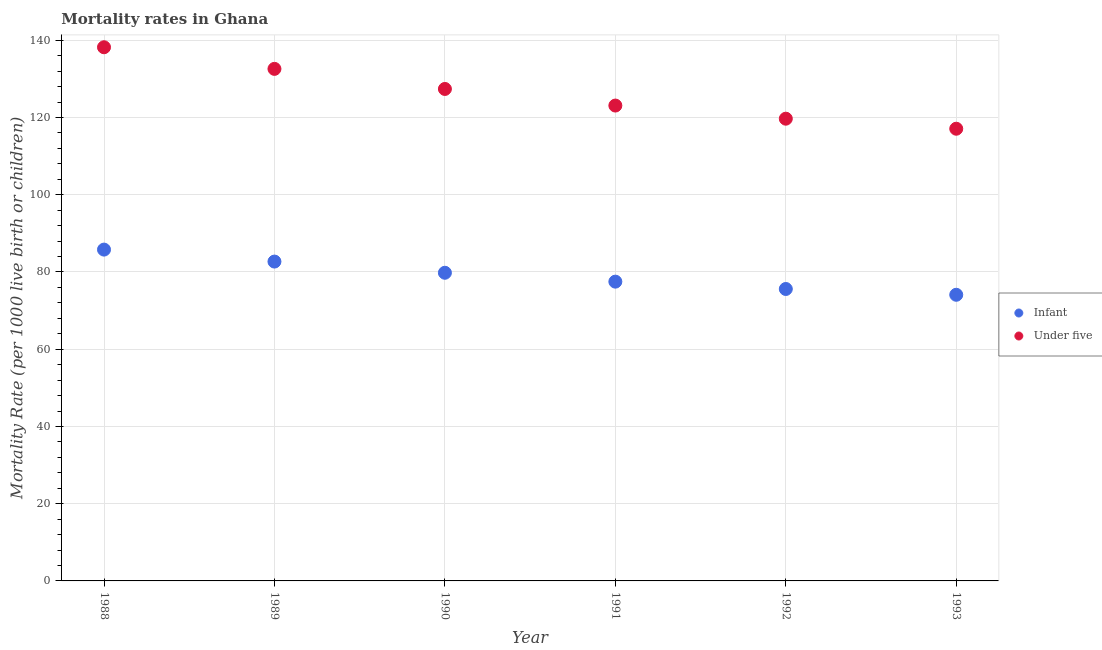Is the number of dotlines equal to the number of legend labels?
Ensure brevity in your answer.  Yes. What is the infant mortality rate in 1993?
Provide a short and direct response. 74.1. Across all years, what is the maximum infant mortality rate?
Your response must be concise. 85.8. Across all years, what is the minimum under-5 mortality rate?
Offer a very short reply. 117.1. In which year was the infant mortality rate maximum?
Give a very brief answer. 1988. What is the total infant mortality rate in the graph?
Your answer should be compact. 475.5. What is the difference between the infant mortality rate in 1988 and that in 1990?
Provide a succinct answer. 6. What is the difference between the infant mortality rate in 1993 and the under-5 mortality rate in 1992?
Offer a very short reply. -45.6. What is the average infant mortality rate per year?
Ensure brevity in your answer.  79.25. In the year 1993, what is the difference between the under-5 mortality rate and infant mortality rate?
Make the answer very short. 43. What is the ratio of the infant mortality rate in 1989 to that in 1990?
Keep it short and to the point. 1.04. Is the difference between the infant mortality rate in 1991 and 1992 greater than the difference between the under-5 mortality rate in 1991 and 1992?
Offer a very short reply. No. What is the difference between the highest and the second highest infant mortality rate?
Make the answer very short. 3.1. What is the difference between the highest and the lowest under-5 mortality rate?
Provide a short and direct response. 21.1. In how many years, is the under-5 mortality rate greater than the average under-5 mortality rate taken over all years?
Keep it short and to the point. 3. Is the sum of the infant mortality rate in 1992 and 1993 greater than the maximum under-5 mortality rate across all years?
Give a very brief answer. Yes. Is the under-5 mortality rate strictly less than the infant mortality rate over the years?
Offer a very short reply. No. How many dotlines are there?
Ensure brevity in your answer.  2. What is the difference between two consecutive major ticks on the Y-axis?
Your answer should be very brief. 20. Are the values on the major ticks of Y-axis written in scientific E-notation?
Keep it short and to the point. No. Does the graph contain any zero values?
Offer a terse response. No. Where does the legend appear in the graph?
Provide a succinct answer. Center right. How many legend labels are there?
Ensure brevity in your answer.  2. How are the legend labels stacked?
Your response must be concise. Vertical. What is the title of the graph?
Your response must be concise. Mortality rates in Ghana. Does "From human activities" appear as one of the legend labels in the graph?
Give a very brief answer. No. What is the label or title of the X-axis?
Make the answer very short. Year. What is the label or title of the Y-axis?
Your response must be concise. Mortality Rate (per 1000 live birth or children). What is the Mortality Rate (per 1000 live birth or children) in Infant in 1988?
Provide a succinct answer. 85.8. What is the Mortality Rate (per 1000 live birth or children) of Under five in 1988?
Your response must be concise. 138.2. What is the Mortality Rate (per 1000 live birth or children) in Infant in 1989?
Offer a very short reply. 82.7. What is the Mortality Rate (per 1000 live birth or children) in Under five in 1989?
Offer a very short reply. 132.6. What is the Mortality Rate (per 1000 live birth or children) of Infant in 1990?
Offer a terse response. 79.8. What is the Mortality Rate (per 1000 live birth or children) of Under five in 1990?
Ensure brevity in your answer.  127.4. What is the Mortality Rate (per 1000 live birth or children) of Infant in 1991?
Your response must be concise. 77.5. What is the Mortality Rate (per 1000 live birth or children) in Under five in 1991?
Give a very brief answer. 123.1. What is the Mortality Rate (per 1000 live birth or children) in Infant in 1992?
Your answer should be very brief. 75.6. What is the Mortality Rate (per 1000 live birth or children) in Under five in 1992?
Your answer should be very brief. 119.7. What is the Mortality Rate (per 1000 live birth or children) in Infant in 1993?
Ensure brevity in your answer.  74.1. What is the Mortality Rate (per 1000 live birth or children) in Under five in 1993?
Provide a short and direct response. 117.1. Across all years, what is the maximum Mortality Rate (per 1000 live birth or children) of Infant?
Provide a succinct answer. 85.8. Across all years, what is the maximum Mortality Rate (per 1000 live birth or children) in Under five?
Ensure brevity in your answer.  138.2. Across all years, what is the minimum Mortality Rate (per 1000 live birth or children) of Infant?
Offer a terse response. 74.1. Across all years, what is the minimum Mortality Rate (per 1000 live birth or children) in Under five?
Your answer should be compact. 117.1. What is the total Mortality Rate (per 1000 live birth or children) in Infant in the graph?
Offer a very short reply. 475.5. What is the total Mortality Rate (per 1000 live birth or children) in Under five in the graph?
Offer a very short reply. 758.1. What is the difference between the Mortality Rate (per 1000 live birth or children) of Under five in 1988 and that in 1989?
Your answer should be compact. 5.6. What is the difference between the Mortality Rate (per 1000 live birth or children) in Infant in 1988 and that in 1991?
Offer a terse response. 8.3. What is the difference between the Mortality Rate (per 1000 live birth or children) in Infant in 1988 and that in 1992?
Offer a terse response. 10.2. What is the difference between the Mortality Rate (per 1000 live birth or children) in Infant in 1988 and that in 1993?
Make the answer very short. 11.7. What is the difference between the Mortality Rate (per 1000 live birth or children) of Under five in 1988 and that in 1993?
Give a very brief answer. 21.1. What is the difference between the Mortality Rate (per 1000 live birth or children) in Infant in 1989 and that in 1990?
Your response must be concise. 2.9. What is the difference between the Mortality Rate (per 1000 live birth or children) of Under five in 1989 and that in 1990?
Provide a short and direct response. 5.2. What is the difference between the Mortality Rate (per 1000 live birth or children) of Infant in 1989 and that in 1991?
Ensure brevity in your answer.  5.2. What is the difference between the Mortality Rate (per 1000 live birth or children) of Under five in 1989 and that in 1991?
Your answer should be very brief. 9.5. What is the difference between the Mortality Rate (per 1000 live birth or children) of Under five in 1989 and that in 1992?
Make the answer very short. 12.9. What is the difference between the Mortality Rate (per 1000 live birth or children) of Infant in 1990 and that in 1991?
Keep it short and to the point. 2.3. What is the difference between the Mortality Rate (per 1000 live birth or children) in Infant in 1990 and that in 1992?
Ensure brevity in your answer.  4.2. What is the difference between the Mortality Rate (per 1000 live birth or children) of Under five in 1990 and that in 1993?
Keep it short and to the point. 10.3. What is the difference between the Mortality Rate (per 1000 live birth or children) of Infant in 1991 and that in 1993?
Offer a terse response. 3.4. What is the difference between the Mortality Rate (per 1000 live birth or children) of Infant in 1988 and the Mortality Rate (per 1000 live birth or children) of Under five in 1989?
Ensure brevity in your answer.  -46.8. What is the difference between the Mortality Rate (per 1000 live birth or children) of Infant in 1988 and the Mortality Rate (per 1000 live birth or children) of Under five in 1990?
Your answer should be very brief. -41.6. What is the difference between the Mortality Rate (per 1000 live birth or children) in Infant in 1988 and the Mortality Rate (per 1000 live birth or children) in Under five in 1991?
Give a very brief answer. -37.3. What is the difference between the Mortality Rate (per 1000 live birth or children) in Infant in 1988 and the Mortality Rate (per 1000 live birth or children) in Under five in 1992?
Your response must be concise. -33.9. What is the difference between the Mortality Rate (per 1000 live birth or children) of Infant in 1988 and the Mortality Rate (per 1000 live birth or children) of Under five in 1993?
Keep it short and to the point. -31.3. What is the difference between the Mortality Rate (per 1000 live birth or children) of Infant in 1989 and the Mortality Rate (per 1000 live birth or children) of Under five in 1990?
Your answer should be compact. -44.7. What is the difference between the Mortality Rate (per 1000 live birth or children) in Infant in 1989 and the Mortality Rate (per 1000 live birth or children) in Under five in 1991?
Your response must be concise. -40.4. What is the difference between the Mortality Rate (per 1000 live birth or children) in Infant in 1989 and the Mortality Rate (per 1000 live birth or children) in Under five in 1992?
Make the answer very short. -37. What is the difference between the Mortality Rate (per 1000 live birth or children) of Infant in 1989 and the Mortality Rate (per 1000 live birth or children) of Under five in 1993?
Your answer should be compact. -34.4. What is the difference between the Mortality Rate (per 1000 live birth or children) of Infant in 1990 and the Mortality Rate (per 1000 live birth or children) of Under five in 1991?
Offer a very short reply. -43.3. What is the difference between the Mortality Rate (per 1000 live birth or children) in Infant in 1990 and the Mortality Rate (per 1000 live birth or children) in Under five in 1992?
Provide a succinct answer. -39.9. What is the difference between the Mortality Rate (per 1000 live birth or children) in Infant in 1990 and the Mortality Rate (per 1000 live birth or children) in Under five in 1993?
Keep it short and to the point. -37.3. What is the difference between the Mortality Rate (per 1000 live birth or children) of Infant in 1991 and the Mortality Rate (per 1000 live birth or children) of Under five in 1992?
Provide a succinct answer. -42.2. What is the difference between the Mortality Rate (per 1000 live birth or children) in Infant in 1991 and the Mortality Rate (per 1000 live birth or children) in Under five in 1993?
Make the answer very short. -39.6. What is the difference between the Mortality Rate (per 1000 live birth or children) in Infant in 1992 and the Mortality Rate (per 1000 live birth or children) in Under five in 1993?
Ensure brevity in your answer.  -41.5. What is the average Mortality Rate (per 1000 live birth or children) in Infant per year?
Make the answer very short. 79.25. What is the average Mortality Rate (per 1000 live birth or children) in Under five per year?
Your answer should be very brief. 126.35. In the year 1988, what is the difference between the Mortality Rate (per 1000 live birth or children) of Infant and Mortality Rate (per 1000 live birth or children) of Under five?
Offer a very short reply. -52.4. In the year 1989, what is the difference between the Mortality Rate (per 1000 live birth or children) of Infant and Mortality Rate (per 1000 live birth or children) of Under five?
Offer a very short reply. -49.9. In the year 1990, what is the difference between the Mortality Rate (per 1000 live birth or children) of Infant and Mortality Rate (per 1000 live birth or children) of Under five?
Provide a short and direct response. -47.6. In the year 1991, what is the difference between the Mortality Rate (per 1000 live birth or children) in Infant and Mortality Rate (per 1000 live birth or children) in Under five?
Make the answer very short. -45.6. In the year 1992, what is the difference between the Mortality Rate (per 1000 live birth or children) in Infant and Mortality Rate (per 1000 live birth or children) in Under five?
Offer a very short reply. -44.1. In the year 1993, what is the difference between the Mortality Rate (per 1000 live birth or children) of Infant and Mortality Rate (per 1000 live birth or children) of Under five?
Provide a short and direct response. -43. What is the ratio of the Mortality Rate (per 1000 live birth or children) in Infant in 1988 to that in 1989?
Keep it short and to the point. 1.04. What is the ratio of the Mortality Rate (per 1000 live birth or children) in Under five in 1988 to that in 1989?
Give a very brief answer. 1.04. What is the ratio of the Mortality Rate (per 1000 live birth or children) in Infant in 1988 to that in 1990?
Make the answer very short. 1.08. What is the ratio of the Mortality Rate (per 1000 live birth or children) of Under five in 1988 to that in 1990?
Ensure brevity in your answer.  1.08. What is the ratio of the Mortality Rate (per 1000 live birth or children) of Infant in 1988 to that in 1991?
Ensure brevity in your answer.  1.11. What is the ratio of the Mortality Rate (per 1000 live birth or children) of Under five in 1988 to that in 1991?
Offer a very short reply. 1.12. What is the ratio of the Mortality Rate (per 1000 live birth or children) of Infant in 1988 to that in 1992?
Provide a short and direct response. 1.13. What is the ratio of the Mortality Rate (per 1000 live birth or children) in Under five in 1988 to that in 1992?
Offer a terse response. 1.15. What is the ratio of the Mortality Rate (per 1000 live birth or children) in Infant in 1988 to that in 1993?
Give a very brief answer. 1.16. What is the ratio of the Mortality Rate (per 1000 live birth or children) in Under five in 1988 to that in 1993?
Give a very brief answer. 1.18. What is the ratio of the Mortality Rate (per 1000 live birth or children) in Infant in 1989 to that in 1990?
Your answer should be very brief. 1.04. What is the ratio of the Mortality Rate (per 1000 live birth or children) in Under five in 1989 to that in 1990?
Offer a very short reply. 1.04. What is the ratio of the Mortality Rate (per 1000 live birth or children) of Infant in 1989 to that in 1991?
Ensure brevity in your answer.  1.07. What is the ratio of the Mortality Rate (per 1000 live birth or children) in Under five in 1989 to that in 1991?
Ensure brevity in your answer.  1.08. What is the ratio of the Mortality Rate (per 1000 live birth or children) of Infant in 1989 to that in 1992?
Give a very brief answer. 1.09. What is the ratio of the Mortality Rate (per 1000 live birth or children) of Under five in 1989 to that in 1992?
Your answer should be compact. 1.11. What is the ratio of the Mortality Rate (per 1000 live birth or children) in Infant in 1989 to that in 1993?
Offer a terse response. 1.12. What is the ratio of the Mortality Rate (per 1000 live birth or children) in Under five in 1989 to that in 1993?
Offer a very short reply. 1.13. What is the ratio of the Mortality Rate (per 1000 live birth or children) in Infant in 1990 to that in 1991?
Give a very brief answer. 1.03. What is the ratio of the Mortality Rate (per 1000 live birth or children) in Under five in 1990 to that in 1991?
Offer a very short reply. 1.03. What is the ratio of the Mortality Rate (per 1000 live birth or children) of Infant in 1990 to that in 1992?
Your response must be concise. 1.06. What is the ratio of the Mortality Rate (per 1000 live birth or children) of Under five in 1990 to that in 1992?
Ensure brevity in your answer.  1.06. What is the ratio of the Mortality Rate (per 1000 live birth or children) in Under five in 1990 to that in 1993?
Give a very brief answer. 1.09. What is the ratio of the Mortality Rate (per 1000 live birth or children) of Infant in 1991 to that in 1992?
Make the answer very short. 1.03. What is the ratio of the Mortality Rate (per 1000 live birth or children) in Under five in 1991 to that in 1992?
Provide a short and direct response. 1.03. What is the ratio of the Mortality Rate (per 1000 live birth or children) in Infant in 1991 to that in 1993?
Provide a short and direct response. 1.05. What is the ratio of the Mortality Rate (per 1000 live birth or children) in Under five in 1991 to that in 1993?
Provide a succinct answer. 1.05. What is the ratio of the Mortality Rate (per 1000 live birth or children) in Infant in 1992 to that in 1993?
Offer a terse response. 1.02. What is the ratio of the Mortality Rate (per 1000 live birth or children) of Under five in 1992 to that in 1993?
Your response must be concise. 1.02. What is the difference between the highest and the second highest Mortality Rate (per 1000 live birth or children) of Infant?
Provide a succinct answer. 3.1. What is the difference between the highest and the second highest Mortality Rate (per 1000 live birth or children) in Under five?
Make the answer very short. 5.6. What is the difference between the highest and the lowest Mortality Rate (per 1000 live birth or children) in Infant?
Offer a very short reply. 11.7. What is the difference between the highest and the lowest Mortality Rate (per 1000 live birth or children) of Under five?
Make the answer very short. 21.1. 